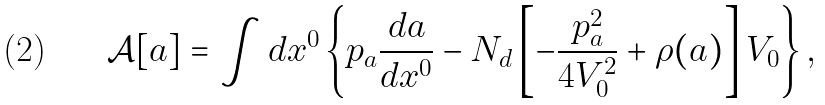<formula> <loc_0><loc_0><loc_500><loc_500>\mathcal { A } [ a ] = \int { d x ^ { 0 } } \left \{ p _ { a } \frac { d a } { d x ^ { 0 } } - N _ { d } \left [ - \frac { p _ { a } ^ { 2 } } { 4 V _ { 0 } ^ { 2 } } + \rho ( a ) \right ] V _ { 0 } \right \} ,</formula> 